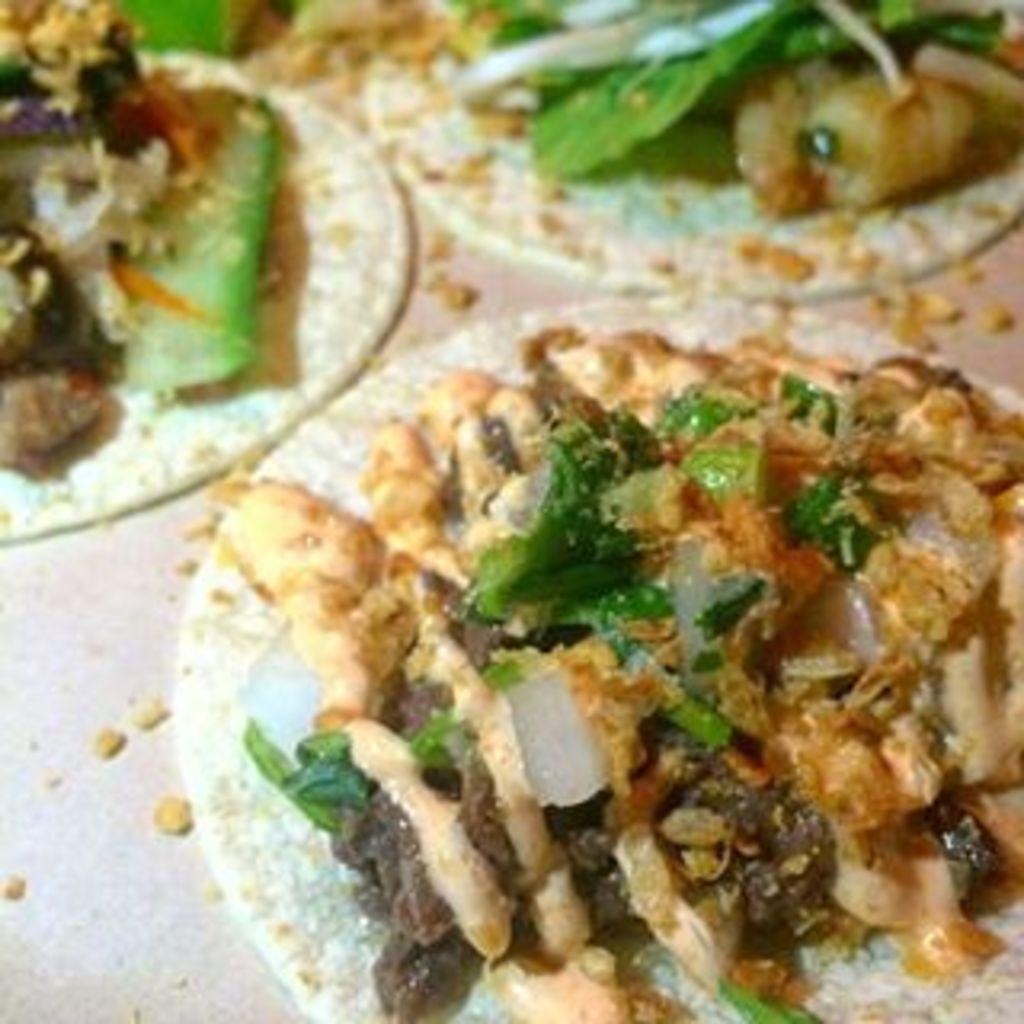How would you summarize this image in a sentence or two? In the image we can see there are food items kept on the table. 